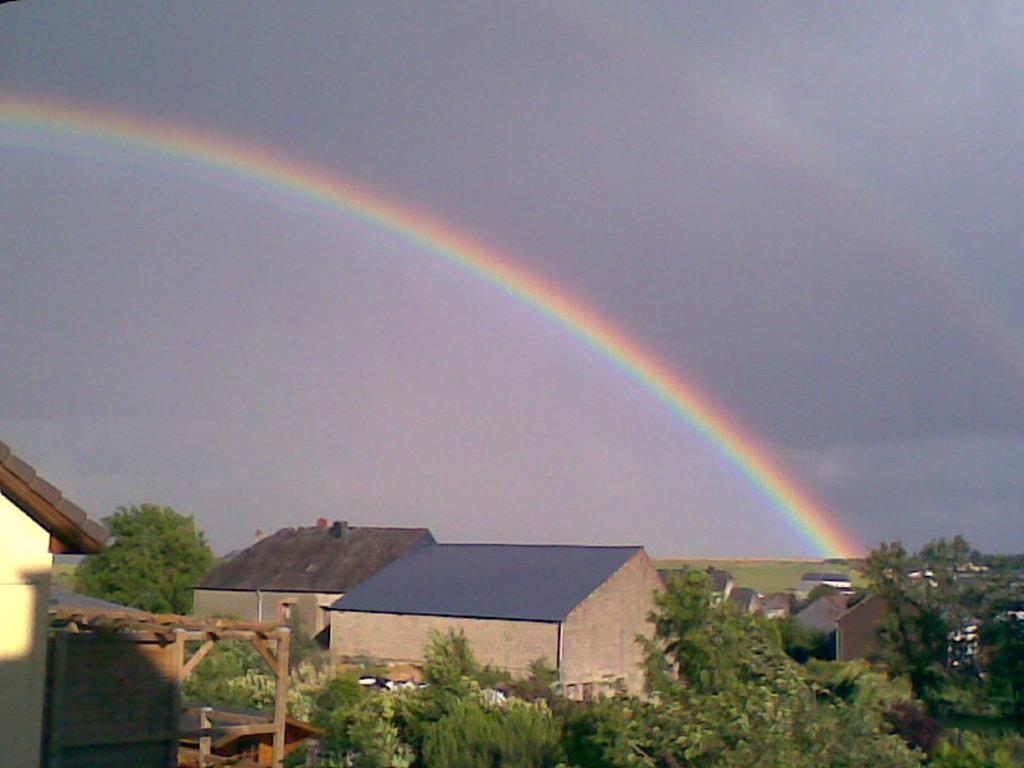Can you describe this image briefly? In this picture I can see there are buildings, trees and there is a rainbow in the sky and in the backdrop there's another rainbow and the sky is cloudy. 